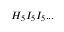Convert formula to latex. <formula><loc_0><loc_0><loc_500><loc_500>H _ { 5 } I _ { 5 } I _ { 5 } \dots</formula> 